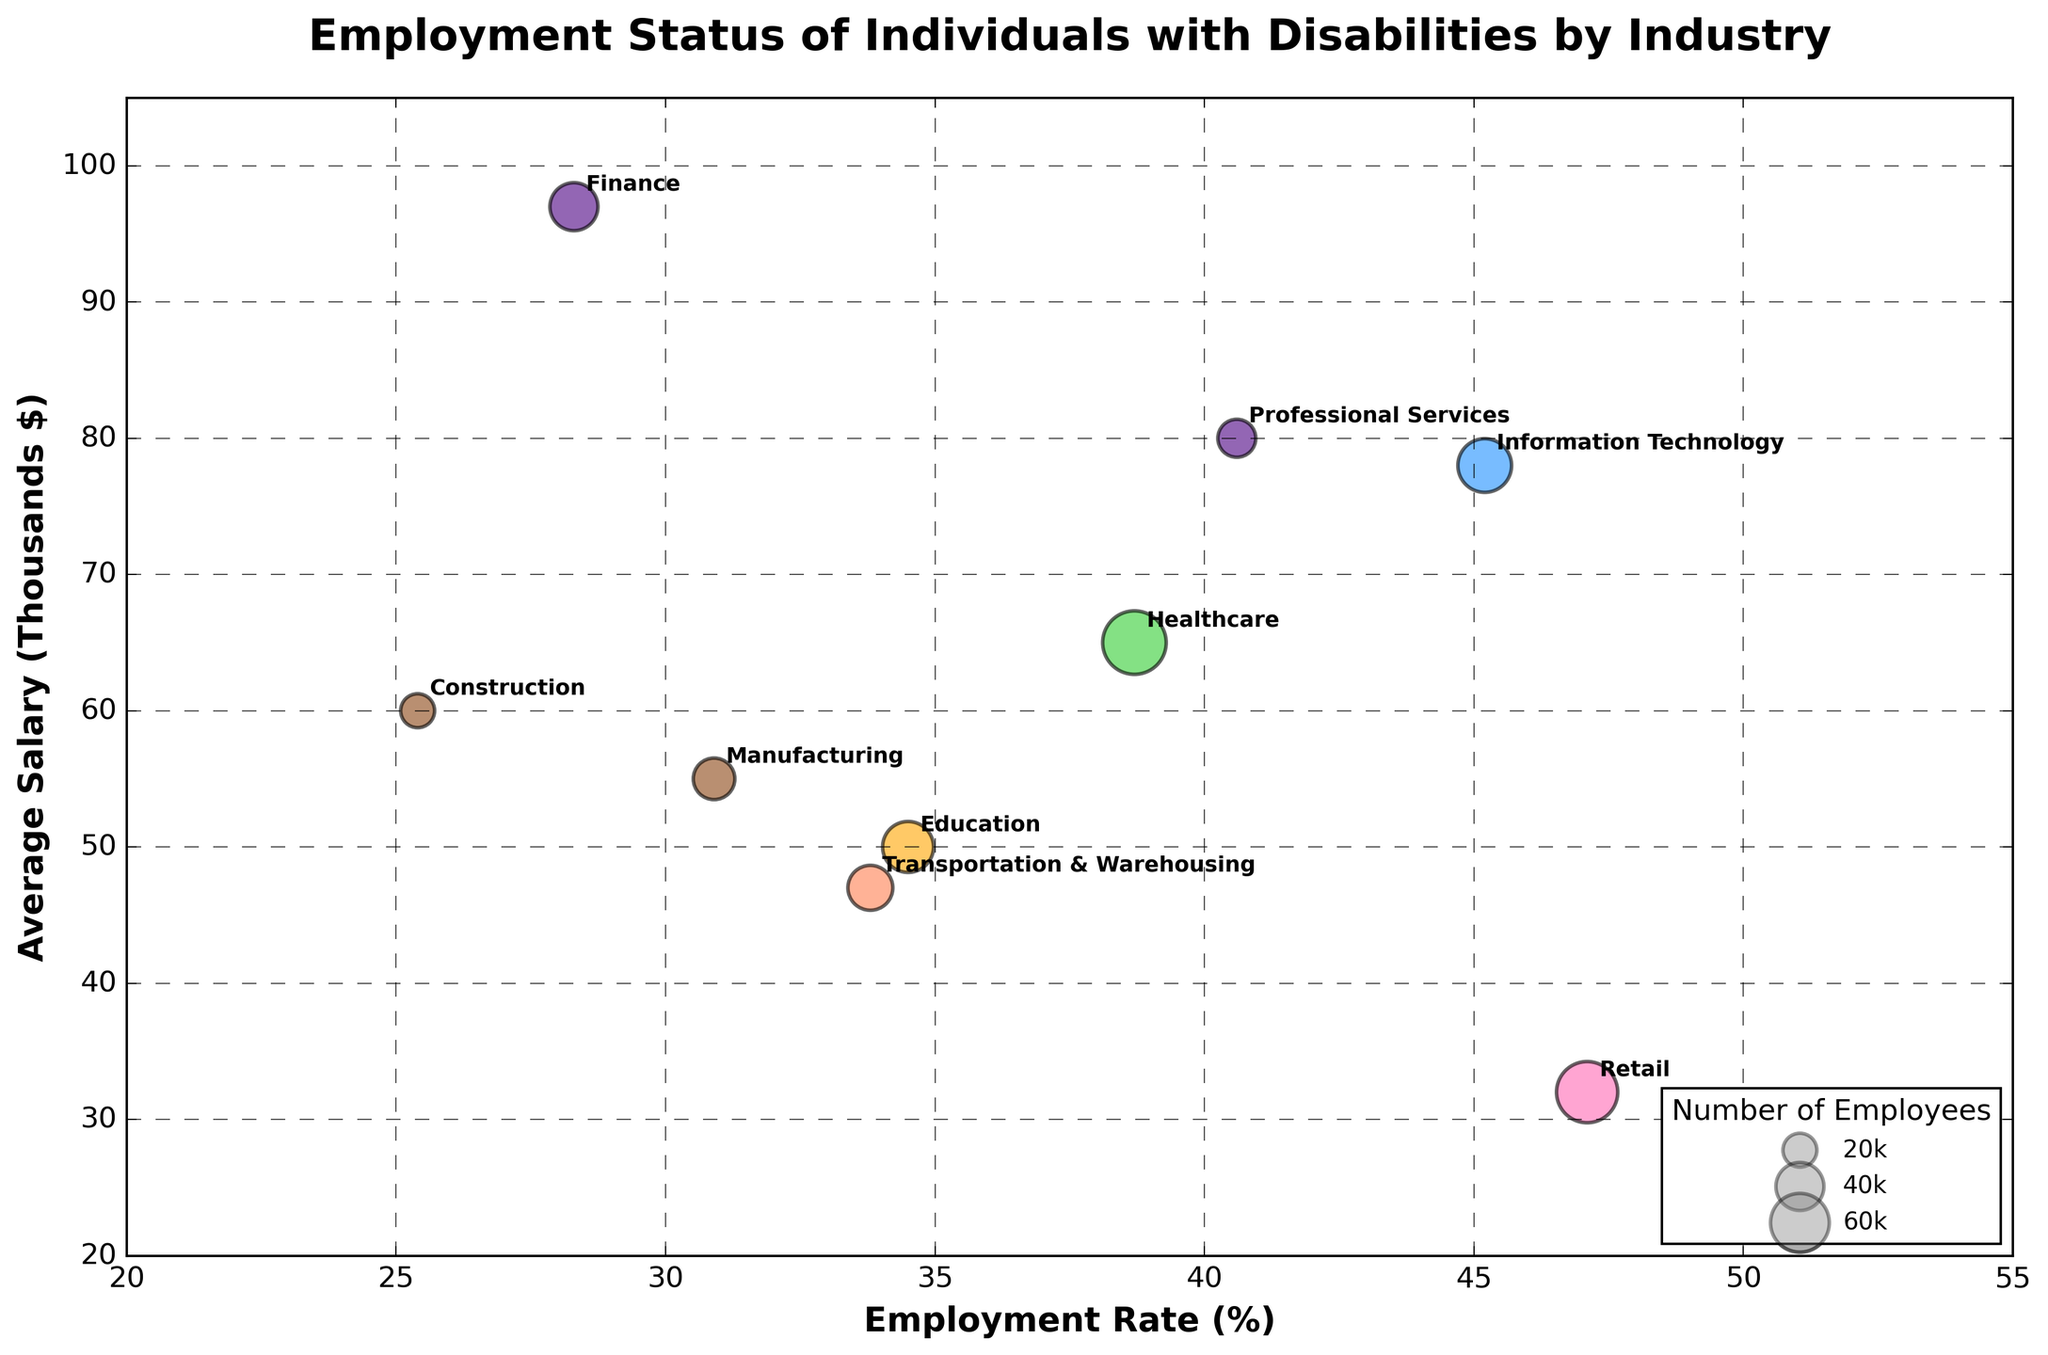What is the title of the plot? The title is usually situated at the top of the plot in the center. In this plot, the title reads "Employment Status of Individuals with Disabilities by Industry".
Answer: Employment Status of Individuals with Disabilities by Industry What are the axes labeled in the plot? The axes provide context for the data displayed. The x-axis is labeled "Employment Rate (%)" and the y-axis is labeled "Average Salary (Thousands $)".
Answer: Employment Rate (%) and Average Salary (Thousands $) Which industry has the highest employment rate? By looking at the x-axis (Employment Rate %), the farthest point to the right represents the highest employment rate. In this plot, that industry is "Hospitality" with an employment rate of 52%.
Answer: Hospitality How many industry sectors are represented by different colors in the plot? Different colors represent different sectors in the legend. Counting the unique entries in the legend, we have colors for Tech, Health, Public Services, General Services, Industrial, Corporate, and Logistics.
Answer: Seven What industry has both an average salary above $70,000 and an employment rate below 30%? First, find the bubbles above the $70 range on the y-axis, then check the ones that also lie to the left of the 30% mark on the x-axis. The "Finance" industry fits both criteria.
Answer: Finance Which sector has the most number of employees and what is that number? Look at the largest bubble size and find its corresponding label. The largest bubble is in the Healthcare sector with 70,000 employees.
Answer: Healthcare, 70k How does the average salary in the Healthcare sector compare to the Education sector? Locate both sectors on the y-axis to compare their average salaries. Healthcare is at $65,000, whereas Education is at $50,000.
Answer: Healthcare > Education Among Tech and Corporate sectors, which has a higher employment rate on average? Examine the bubbles labeled under Tech and Corporate sectors and calculate the average employment rate. Tech has one entry at 45.2% and Corporate has two at 28.3% and 40.6% (averaging approximately 34.45%). Thus, Tech is higher.
Answer: Tech What is the difference in average salary between the highest-paying and lowest-paying industry? Find the highest and lowest points on the y-axis. The Finance industry has the highest average salary at $97,000, and Hospitality has the lowest at $28,000. The difference is $97,000 - $28,000 = $69,000.
Answer: $69,000 Which sector has the widest range of employment rates within its industries? Check the variation in employment rates for each sector across their respective bubbles. The General Services sector spans from Retail at 47.1% to Hospitality at 52%, showing a variation of about 4.9%. However, the Tech sector goes from 28.3% (Finance) to 40.6% (Professional Services) constituting 12.3% range. This comparison shows the Corporate sector as having the widest range.
Answer: Corporate 